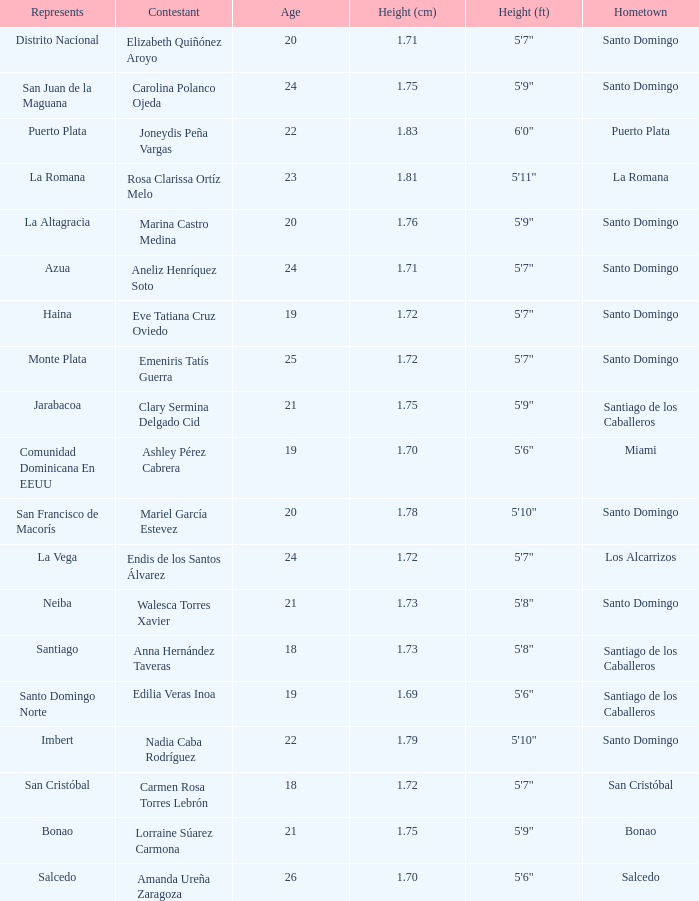Name the most age 26.0. 